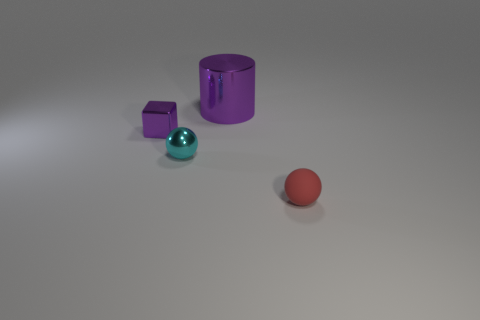There is a cyan metal thing; is its size the same as the purple metallic thing that is in front of the large thing?
Provide a short and direct response. Yes. What color is the matte ball that is the same size as the purple shiny cube?
Keep it short and to the point. Red. What is the size of the red rubber thing?
Offer a terse response. Small. Is the material of the purple thing that is to the right of the small purple metal object the same as the tiny purple object?
Make the answer very short. Yes. Do the cyan object and the red object have the same shape?
Give a very brief answer. Yes. What shape is the tiny cyan object that is right of the small thing that is on the left side of the small ball behind the red thing?
Provide a succinct answer. Sphere. There is a object to the left of the metal ball; does it have the same shape as the object on the right side of the cylinder?
Your answer should be compact. No. Is there a tiny purple thing made of the same material as the cube?
Offer a terse response. No. The tiny metallic object behind the tiny ball that is behind the small sphere in front of the cyan ball is what color?
Give a very brief answer. Purple. Do the sphere to the left of the tiny matte sphere and the purple thing that is to the right of the tiny shiny cube have the same material?
Your answer should be compact. Yes. 